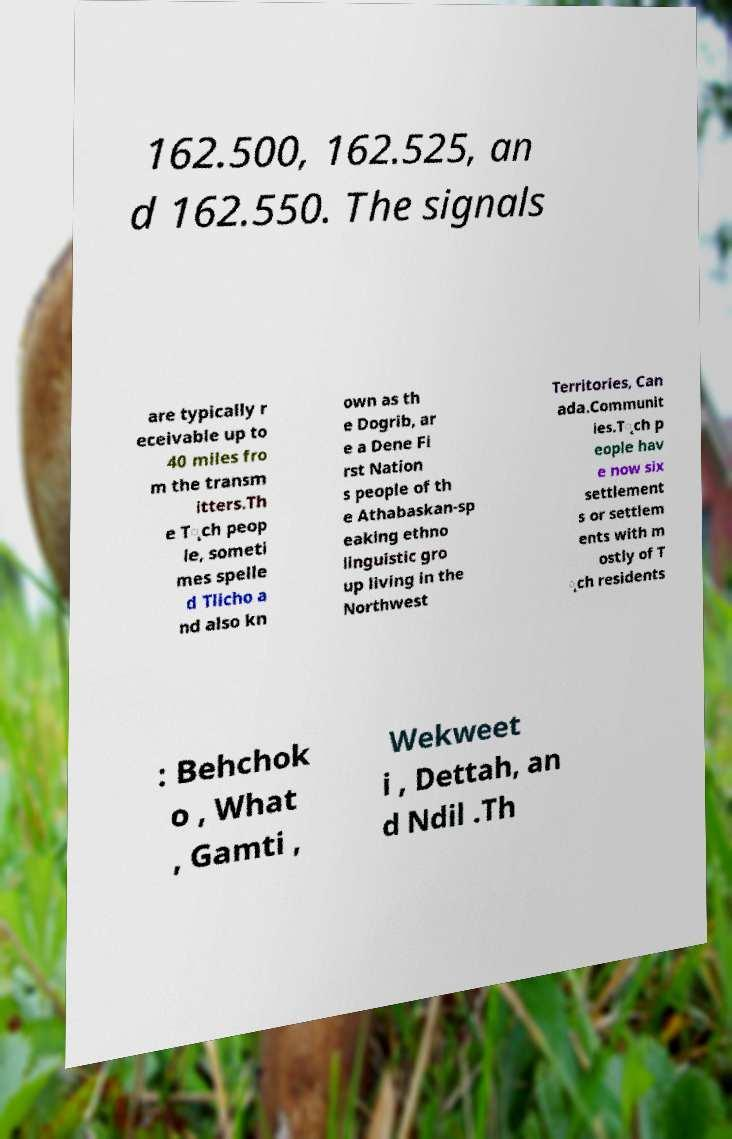Could you extract and type out the text from this image? 162.500, 162.525, an d 162.550. The signals are typically r eceivable up to 40 miles fro m the transm itters.Th e T̨ch peop le, someti mes spelle d Tlicho a nd also kn own as th e Dogrib, ar e a Dene Fi rst Nation s people of th e Athabaskan-sp eaking ethno linguistic gro up living in the Northwest Territories, Can ada.Communit ies.T̨ch p eople hav e now six settlement s or settlem ents with m ostly of T ̨ch residents : Behchok o , What , Gamti , Wekweet i , Dettah, an d Ndil .Th 